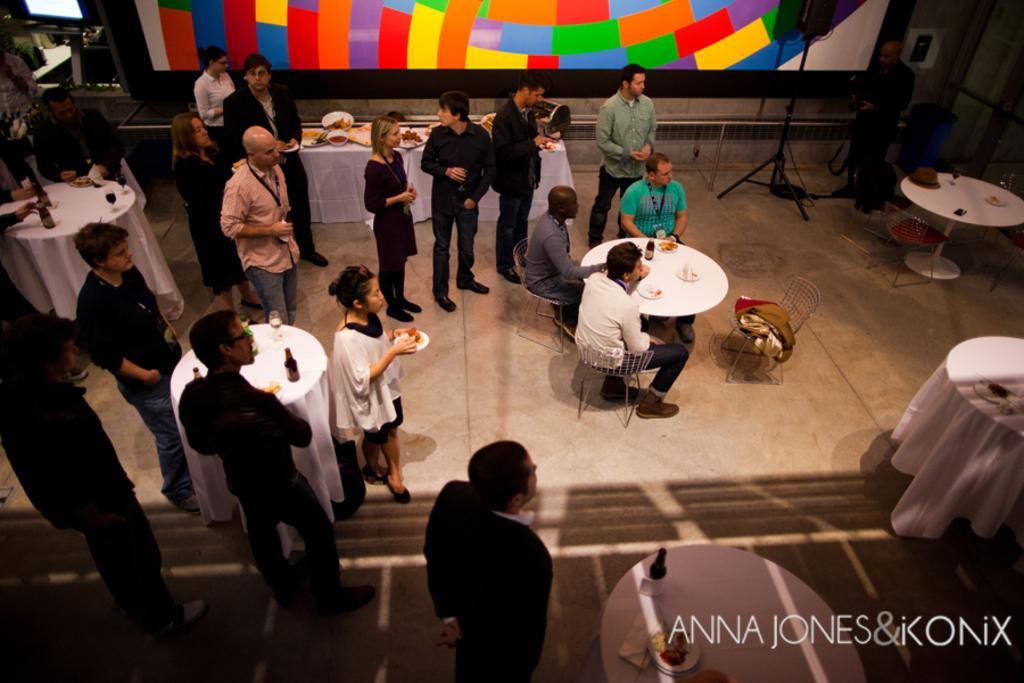Can you describe this image briefly? As we can see in the image there is a wall, few people standing and sitting here and there and there are chairs and tables. On tables there are bottles and glasses. 